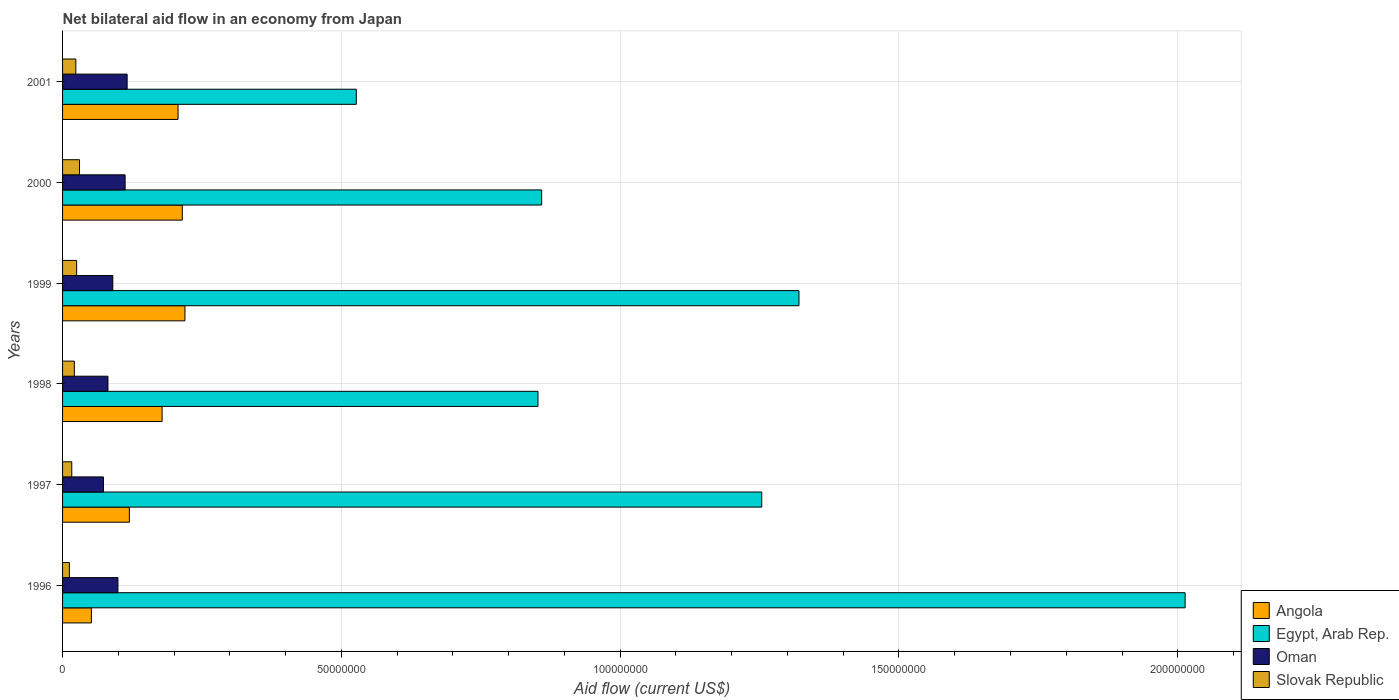How many different coloured bars are there?
Your response must be concise. 4. Are the number of bars on each tick of the Y-axis equal?
Provide a succinct answer. Yes. How many bars are there on the 1st tick from the top?
Provide a short and direct response. 4. How many bars are there on the 6th tick from the bottom?
Ensure brevity in your answer.  4. What is the label of the 6th group of bars from the top?
Provide a succinct answer. 1996. In how many cases, is the number of bars for a given year not equal to the number of legend labels?
Your answer should be compact. 0. What is the net bilateral aid flow in Oman in 1999?
Your response must be concise. 9.01e+06. Across all years, what is the maximum net bilateral aid flow in Angola?
Offer a very short reply. 2.20e+07. Across all years, what is the minimum net bilateral aid flow in Oman?
Provide a short and direct response. 7.33e+06. In which year was the net bilateral aid flow in Egypt, Arab Rep. maximum?
Provide a succinct answer. 1996. What is the total net bilateral aid flow in Slovak Republic in the graph?
Provide a succinct answer. 1.29e+07. What is the difference between the net bilateral aid flow in Angola in 1996 and that in 2001?
Give a very brief answer. -1.55e+07. What is the difference between the net bilateral aid flow in Oman in 2001 and the net bilateral aid flow in Egypt, Arab Rep. in 1999?
Provide a short and direct response. -1.20e+08. What is the average net bilateral aid flow in Oman per year?
Provide a short and direct response. 9.54e+06. In the year 1996, what is the difference between the net bilateral aid flow in Angola and net bilateral aid flow in Egypt, Arab Rep.?
Offer a terse response. -1.96e+08. What is the ratio of the net bilateral aid flow in Angola in 1999 to that in 2001?
Ensure brevity in your answer.  1.06. What is the difference between the highest and the second highest net bilateral aid flow in Egypt, Arab Rep.?
Your answer should be compact. 6.92e+07. What is the difference between the highest and the lowest net bilateral aid flow in Angola?
Offer a very short reply. 1.68e+07. In how many years, is the net bilateral aid flow in Angola greater than the average net bilateral aid flow in Angola taken over all years?
Your response must be concise. 4. Is it the case that in every year, the sum of the net bilateral aid flow in Egypt, Arab Rep. and net bilateral aid flow in Slovak Republic is greater than the sum of net bilateral aid flow in Oman and net bilateral aid flow in Angola?
Your answer should be very brief. No. What does the 4th bar from the top in 1997 represents?
Provide a succinct answer. Angola. What does the 1st bar from the bottom in 1997 represents?
Your answer should be very brief. Angola. Is it the case that in every year, the sum of the net bilateral aid flow in Oman and net bilateral aid flow in Slovak Republic is greater than the net bilateral aid flow in Egypt, Arab Rep.?
Your response must be concise. No. What is the difference between two consecutive major ticks on the X-axis?
Your response must be concise. 5.00e+07. Does the graph contain any zero values?
Your answer should be compact. No. Does the graph contain grids?
Ensure brevity in your answer.  Yes. How many legend labels are there?
Offer a very short reply. 4. What is the title of the graph?
Offer a very short reply. Net bilateral aid flow in an economy from Japan. Does "Myanmar" appear as one of the legend labels in the graph?
Offer a very short reply. No. What is the Aid flow (current US$) in Angola in 1996?
Ensure brevity in your answer.  5.17e+06. What is the Aid flow (current US$) in Egypt, Arab Rep. in 1996?
Provide a short and direct response. 2.01e+08. What is the Aid flow (current US$) in Oman in 1996?
Your answer should be compact. 9.93e+06. What is the Aid flow (current US$) in Slovak Republic in 1996?
Give a very brief answer. 1.22e+06. What is the Aid flow (current US$) of Angola in 1997?
Offer a very short reply. 1.20e+07. What is the Aid flow (current US$) in Egypt, Arab Rep. in 1997?
Keep it short and to the point. 1.25e+08. What is the Aid flow (current US$) in Oman in 1997?
Your answer should be compact. 7.33e+06. What is the Aid flow (current US$) in Slovak Republic in 1997?
Offer a very short reply. 1.65e+06. What is the Aid flow (current US$) of Angola in 1998?
Provide a succinct answer. 1.78e+07. What is the Aid flow (current US$) in Egypt, Arab Rep. in 1998?
Offer a terse response. 8.53e+07. What is the Aid flow (current US$) of Oman in 1998?
Offer a terse response. 8.14e+06. What is the Aid flow (current US$) in Slovak Republic in 1998?
Provide a short and direct response. 2.11e+06. What is the Aid flow (current US$) of Angola in 1999?
Provide a succinct answer. 2.20e+07. What is the Aid flow (current US$) of Egypt, Arab Rep. in 1999?
Provide a succinct answer. 1.32e+08. What is the Aid flow (current US$) of Oman in 1999?
Offer a very short reply. 9.01e+06. What is the Aid flow (current US$) in Slovak Republic in 1999?
Provide a short and direct response. 2.52e+06. What is the Aid flow (current US$) in Angola in 2000?
Provide a succinct answer. 2.15e+07. What is the Aid flow (current US$) of Egypt, Arab Rep. in 2000?
Your answer should be very brief. 8.59e+07. What is the Aid flow (current US$) of Oman in 2000?
Offer a terse response. 1.12e+07. What is the Aid flow (current US$) of Slovak Republic in 2000?
Your answer should be compact. 3.04e+06. What is the Aid flow (current US$) of Angola in 2001?
Provide a succinct answer. 2.07e+07. What is the Aid flow (current US$) of Egypt, Arab Rep. in 2001?
Offer a terse response. 5.27e+07. What is the Aid flow (current US$) of Oman in 2001?
Ensure brevity in your answer.  1.16e+07. What is the Aid flow (current US$) of Slovak Republic in 2001?
Keep it short and to the point. 2.38e+06. Across all years, what is the maximum Aid flow (current US$) of Angola?
Your answer should be compact. 2.20e+07. Across all years, what is the maximum Aid flow (current US$) in Egypt, Arab Rep.?
Your answer should be very brief. 2.01e+08. Across all years, what is the maximum Aid flow (current US$) in Oman?
Your answer should be very brief. 1.16e+07. Across all years, what is the maximum Aid flow (current US$) of Slovak Republic?
Give a very brief answer. 3.04e+06. Across all years, what is the minimum Aid flow (current US$) of Angola?
Offer a very short reply. 5.17e+06. Across all years, what is the minimum Aid flow (current US$) in Egypt, Arab Rep.?
Your response must be concise. 5.27e+07. Across all years, what is the minimum Aid flow (current US$) of Oman?
Give a very brief answer. 7.33e+06. Across all years, what is the minimum Aid flow (current US$) in Slovak Republic?
Provide a short and direct response. 1.22e+06. What is the total Aid flow (current US$) of Angola in the graph?
Ensure brevity in your answer.  9.91e+07. What is the total Aid flow (current US$) in Egypt, Arab Rep. in the graph?
Your answer should be compact. 6.83e+08. What is the total Aid flow (current US$) in Oman in the graph?
Make the answer very short. 5.72e+07. What is the total Aid flow (current US$) in Slovak Republic in the graph?
Keep it short and to the point. 1.29e+07. What is the difference between the Aid flow (current US$) of Angola in 1996 and that in 1997?
Provide a succinct answer. -6.81e+06. What is the difference between the Aid flow (current US$) in Egypt, Arab Rep. in 1996 and that in 1997?
Your answer should be very brief. 7.59e+07. What is the difference between the Aid flow (current US$) of Oman in 1996 and that in 1997?
Provide a succinct answer. 2.60e+06. What is the difference between the Aid flow (current US$) in Slovak Republic in 1996 and that in 1997?
Provide a succinct answer. -4.30e+05. What is the difference between the Aid flow (current US$) in Angola in 1996 and that in 1998?
Provide a short and direct response. -1.27e+07. What is the difference between the Aid flow (current US$) in Egypt, Arab Rep. in 1996 and that in 1998?
Offer a very short reply. 1.16e+08. What is the difference between the Aid flow (current US$) of Oman in 1996 and that in 1998?
Ensure brevity in your answer.  1.79e+06. What is the difference between the Aid flow (current US$) in Slovak Republic in 1996 and that in 1998?
Give a very brief answer. -8.90e+05. What is the difference between the Aid flow (current US$) in Angola in 1996 and that in 1999?
Make the answer very short. -1.68e+07. What is the difference between the Aid flow (current US$) in Egypt, Arab Rep. in 1996 and that in 1999?
Provide a short and direct response. 6.92e+07. What is the difference between the Aid flow (current US$) in Oman in 1996 and that in 1999?
Your answer should be very brief. 9.20e+05. What is the difference between the Aid flow (current US$) in Slovak Republic in 1996 and that in 1999?
Offer a very short reply. -1.30e+06. What is the difference between the Aid flow (current US$) in Angola in 1996 and that in 2000?
Provide a succinct answer. -1.63e+07. What is the difference between the Aid flow (current US$) in Egypt, Arab Rep. in 1996 and that in 2000?
Offer a very short reply. 1.15e+08. What is the difference between the Aid flow (current US$) of Oman in 1996 and that in 2000?
Offer a terse response. -1.29e+06. What is the difference between the Aid flow (current US$) of Slovak Republic in 1996 and that in 2000?
Your response must be concise. -1.82e+06. What is the difference between the Aid flow (current US$) in Angola in 1996 and that in 2001?
Provide a short and direct response. -1.55e+07. What is the difference between the Aid flow (current US$) of Egypt, Arab Rep. in 1996 and that in 2001?
Your answer should be compact. 1.49e+08. What is the difference between the Aid flow (current US$) in Oman in 1996 and that in 2001?
Ensure brevity in your answer.  -1.65e+06. What is the difference between the Aid flow (current US$) in Slovak Republic in 1996 and that in 2001?
Your response must be concise. -1.16e+06. What is the difference between the Aid flow (current US$) of Angola in 1997 and that in 1998?
Ensure brevity in your answer.  -5.87e+06. What is the difference between the Aid flow (current US$) in Egypt, Arab Rep. in 1997 and that in 1998?
Ensure brevity in your answer.  4.01e+07. What is the difference between the Aid flow (current US$) in Oman in 1997 and that in 1998?
Your response must be concise. -8.10e+05. What is the difference between the Aid flow (current US$) in Slovak Republic in 1997 and that in 1998?
Ensure brevity in your answer.  -4.60e+05. What is the difference between the Aid flow (current US$) of Angola in 1997 and that in 1999?
Provide a short and direct response. -9.97e+06. What is the difference between the Aid flow (current US$) of Egypt, Arab Rep. in 1997 and that in 1999?
Your answer should be compact. -6.68e+06. What is the difference between the Aid flow (current US$) of Oman in 1997 and that in 1999?
Offer a terse response. -1.68e+06. What is the difference between the Aid flow (current US$) in Slovak Republic in 1997 and that in 1999?
Offer a terse response. -8.70e+05. What is the difference between the Aid flow (current US$) in Angola in 1997 and that in 2000?
Offer a very short reply. -9.49e+06. What is the difference between the Aid flow (current US$) of Egypt, Arab Rep. in 1997 and that in 2000?
Your response must be concise. 3.95e+07. What is the difference between the Aid flow (current US$) of Oman in 1997 and that in 2000?
Offer a terse response. -3.89e+06. What is the difference between the Aid flow (current US$) in Slovak Republic in 1997 and that in 2000?
Provide a short and direct response. -1.39e+06. What is the difference between the Aid flow (current US$) in Angola in 1997 and that in 2001?
Your response must be concise. -8.73e+06. What is the difference between the Aid flow (current US$) in Egypt, Arab Rep. in 1997 and that in 2001?
Ensure brevity in your answer.  7.27e+07. What is the difference between the Aid flow (current US$) of Oman in 1997 and that in 2001?
Offer a terse response. -4.25e+06. What is the difference between the Aid flow (current US$) in Slovak Republic in 1997 and that in 2001?
Offer a very short reply. -7.30e+05. What is the difference between the Aid flow (current US$) in Angola in 1998 and that in 1999?
Keep it short and to the point. -4.10e+06. What is the difference between the Aid flow (current US$) of Egypt, Arab Rep. in 1998 and that in 1999?
Give a very brief answer. -4.68e+07. What is the difference between the Aid flow (current US$) of Oman in 1998 and that in 1999?
Keep it short and to the point. -8.70e+05. What is the difference between the Aid flow (current US$) of Slovak Republic in 1998 and that in 1999?
Your answer should be very brief. -4.10e+05. What is the difference between the Aid flow (current US$) in Angola in 1998 and that in 2000?
Keep it short and to the point. -3.62e+06. What is the difference between the Aid flow (current US$) in Egypt, Arab Rep. in 1998 and that in 2000?
Keep it short and to the point. -6.60e+05. What is the difference between the Aid flow (current US$) in Oman in 1998 and that in 2000?
Your response must be concise. -3.08e+06. What is the difference between the Aid flow (current US$) in Slovak Republic in 1998 and that in 2000?
Provide a short and direct response. -9.30e+05. What is the difference between the Aid flow (current US$) of Angola in 1998 and that in 2001?
Make the answer very short. -2.86e+06. What is the difference between the Aid flow (current US$) of Egypt, Arab Rep. in 1998 and that in 2001?
Offer a very short reply. 3.26e+07. What is the difference between the Aid flow (current US$) in Oman in 1998 and that in 2001?
Keep it short and to the point. -3.44e+06. What is the difference between the Aid flow (current US$) of Angola in 1999 and that in 2000?
Provide a short and direct response. 4.80e+05. What is the difference between the Aid flow (current US$) of Egypt, Arab Rep. in 1999 and that in 2000?
Keep it short and to the point. 4.62e+07. What is the difference between the Aid flow (current US$) in Oman in 1999 and that in 2000?
Keep it short and to the point. -2.21e+06. What is the difference between the Aid flow (current US$) in Slovak Republic in 1999 and that in 2000?
Your answer should be compact. -5.20e+05. What is the difference between the Aid flow (current US$) of Angola in 1999 and that in 2001?
Make the answer very short. 1.24e+06. What is the difference between the Aid flow (current US$) of Egypt, Arab Rep. in 1999 and that in 2001?
Your answer should be compact. 7.94e+07. What is the difference between the Aid flow (current US$) in Oman in 1999 and that in 2001?
Offer a very short reply. -2.57e+06. What is the difference between the Aid flow (current US$) of Slovak Republic in 1999 and that in 2001?
Provide a succinct answer. 1.40e+05. What is the difference between the Aid flow (current US$) of Angola in 2000 and that in 2001?
Ensure brevity in your answer.  7.60e+05. What is the difference between the Aid flow (current US$) of Egypt, Arab Rep. in 2000 and that in 2001?
Your answer should be very brief. 3.32e+07. What is the difference between the Aid flow (current US$) in Oman in 2000 and that in 2001?
Offer a very short reply. -3.60e+05. What is the difference between the Aid flow (current US$) of Angola in 1996 and the Aid flow (current US$) of Egypt, Arab Rep. in 1997?
Give a very brief answer. -1.20e+08. What is the difference between the Aid flow (current US$) of Angola in 1996 and the Aid flow (current US$) of Oman in 1997?
Offer a very short reply. -2.16e+06. What is the difference between the Aid flow (current US$) of Angola in 1996 and the Aid flow (current US$) of Slovak Republic in 1997?
Make the answer very short. 3.52e+06. What is the difference between the Aid flow (current US$) in Egypt, Arab Rep. in 1996 and the Aid flow (current US$) in Oman in 1997?
Provide a short and direct response. 1.94e+08. What is the difference between the Aid flow (current US$) of Egypt, Arab Rep. in 1996 and the Aid flow (current US$) of Slovak Republic in 1997?
Your answer should be compact. 2.00e+08. What is the difference between the Aid flow (current US$) in Oman in 1996 and the Aid flow (current US$) in Slovak Republic in 1997?
Give a very brief answer. 8.28e+06. What is the difference between the Aid flow (current US$) of Angola in 1996 and the Aid flow (current US$) of Egypt, Arab Rep. in 1998?
Your answer should be compact. -8.01e+07. What is the difference between the Aid flow (current US$) of Angola in 1996 and the Aid flow (current US$) of Oman in 1998?
Your response must be concise. -2.97e+06. What is the difference between the Aid flow (current US$) of Angola in 1996 and the Aid flow (current US$) of Slovak Republic in 1998?
Your answer should be very brief. 3.06e+06. What is the difference between the Aid flow (current US$) in Egypt, Arab Rep. in 1996 and the Aid flow (current US$) in Oman in 1998?
Ensure brevity in your answer.  1.93e+08. What is the difference between the Aid flow (current US$) in Egypt, Arab Rep. in 1996 and the Aid flow (current US$) in Slovak Republic in 1998?
Keep it short and to the point. 1.99e+08. What is the difference between the Aid flow (current US$) of Oman in 1996 and the Aid flow (current US$) of Slovak Republic in 1998?
Offer a very short reply. 7.82e+06. What is the difference between the Aid flow (current US$) of Angola in 1996 and the Aid flow (current US$) of Egypt, Arab Rep. in 1999?
Keep it short and to the point. -1.27e+08. What is the difference between the Aid flow (current US$) of Angola in 1996 and the Aid flow (current US$) of Oman in 1999?
Provide a succinct answer. -3.84e+06. What is the difference between the Aid flow (current US$) of Angola in 1996 and the Aid flow (current US$) of Slovak Republic in 1999?
Give a very brief answer. 2.65e+06. What is the difference between the Aid flow (current US$) of Egypt, Arab Rep. in 1996 and the Aid flow (current US$) of Oman in 1999?
Provide a short and direct response. 1.92e+08. What is the difference between the Aid flow (current US$) in Egypt, Arab Rep. in 1996 and the Aid flow (current US$) in Slovak Republic in 1999?
Your response must be concise. 1.99e+08. What is the difference between the Aid flow (current US$) of Oman in 1996 and the Aid flow (current US$) of Slovak Republic in 1999?
Your answer should be very brief. 7.41e+06. What is the difference between the Aid flow (current US$) in Angola in 1996 and the Aid flow (current US$) in Egypt, Arab Rep. in 2000?
Your answer should be compact. -8.08e+07. What is the difference between the Aid flow (current US$) in Angola in 1996 and the Aid flow (current US$) in Oman in 2000?
Keep it short and to the point. -6.05e+06. What is the difference between the Aid flow (current US$) of Angola in 1996 and the Aid flow (current US$) of Slovak Republic in 2000?
Give a very brief answer. 2.13e+06. What is the difference between the Aid flow (current US$) of Egypt, Arab Rep. in 1996 and the Aid flow (current US$) of Oman in 2000?
Offer a very short reply. 1.90e+08. What is the difference between the Aid flow (current US$) in Egypt, Arab Rep. in 1996 and the Aid flow (current US$) in Slovak Republic in 2000?
Ensure brevity in your answer.  1.98e+08. What is the difference between the Aid flow (current US$) in Oman in 1996 and the Aid flow (current US$) in Slovak Republic in 2000?
Make the answer very short. 6.89e+06. What is the difference between the Aid flow (current US$) in Angola in 1996 and the Aid flow (current US$) in Egypt, Arab Rep. in 2001?
Keep it short and to the point. -4.75e+07. What is the difference between the Aid flow (current US$) in Angola in 1996 and the Aid flow (current US$) in Oman in 2001?
Your response must be concise. -6.41e+06. What is the difference between the Aid flow (current US$) in Angola in 1996 and the Aid flow (current US$) in Slovak Republic in 2001?
Provide a short and direct response. 2.79e+06. What is the difference between the Aid flow (current US$) of Egypt, Arab Rep. in 1996 and the Aid flow (current US$) of Oman in 2001?
Offer a terse response. 1.90e+08. What is the difference between the Aid flow (current US$) of Egypt, Arab Rep. in 1996 and the Aid flow (current US$) of Slovak Republic in 2001?
Your response must be concise. 1.99e+08. What is the difference between the Aid flow (current US$) of Oman in 1996 and the Aid flow (current US$) of Slovak Republic in 2001?
Provide a short and direct response. 7.55e+06. What is the difference between the Aid flow (current US$) in Angola in 1997 and the Aid flow (current US$) in Egypt, Arab Rep. in 1998?
Keep it short and to the point. -7.33e+07. What is the difference between the Aid flow (current US$) in Angola in 1997 and the Aid flow (current US$) in Oman in 1998?
Provide a short and direct response. 3.84e+06. What is the difference between the Aid flow (current US$) in Angola in 1997 and the Aid flow (current US$) in Slovak Republic in 1998?
Keep it short and to the point. 9.87e+06. What is the difference between the Aid flow (current US$) of Egypt, Arab Rep. in 1997 and the Aid flow (current US$) of Oman in 1998?
Give a very brief answer. 1.17e+08. What is the difference between the Aid flow (current US$) of Egypt, Arab Rep. in 1997 and the Aid flow (current US$) of Slovak Republic in 1998?
Offer a very short reply. 1.23e+08. What is the difference between the Aid flow (current US$) of Oman in 1997 and the Aid flow (current US$) of Slovak Republic in 1998?
Provide a succinct answer. 5.22e+06. What is the difference between the Aid flow (current US$) in Angola in 1997 and the Aid flow (current US$) in Egypt, Arab Rep. in 1999?
Offer a terse response. -1.20e+08. What is the difference between the Aid flow (current US$) in Angola in 1997 and the Aid flow (current US$) in Oman in 1999?
Your answer should be very brief. 2.97e+06. What is the difference between the Aid flow (current US$) in Angola in 1997 and the Aid flow (current US$) in Slovak Republic in 1999?
Your answer should be compact. 9.46e+06. What is the difference between the Aid flow (current US$) in Egypt, Arab Rep. in 1997 and the Aid flow (current US$) in Oman in 1999?
Your response must be concise. 1.16e+08. What is the difference between the Aid flow (current US$) of Egypt, Arab Rep. in 1997 and the Aid flow (current US$) of Slovak Republic in 1999?
Make the answer very short. 1.23e+08. What is the difference between the Aid flow (current US$) in Oman in 1997 and the Aid flow (current US$) in Slovak Republic in 1999?
Your answer should be compact. 4.81e+06. What is the difference between the Aid flow (current US$) of Angola in 1997 and the Aid flow (current US$) of Egypt, Arab Rep. in 2000?
Your response must be concise. -7.39e+07. What is the difference between the Aid flow (current US$) of Angola in 1997 and the Aid flow (current US$) of Oman in 2000?
Offer a very short reply. 7.60e+05. What is the difference between the Aid flow (current US$) of Angola in 1997 and the Aid flow (current US$) of Slovak Republic in 2000?
Offer a very short reply. 8.94e+06. What is the difference between the Aid flow (current US$) of Egypt, Arab Rep. in 1997 and the Aid flow (current US$) of Oman in 2000?
Make the answer very short. 1.14e+08. What is the difference between the Aid flow (current US$) of Egypt, Arab Rep. in 1997 and the Aid flow (current US$) of Slovak Republic in 2000?
Your answer should be compact. 1.22e+08. What is the difference between the Aid flow (current US$) in Oman in 1997 and the Aid flow (current US$) in Slovak Republic in 2000?
Your answer should be very brief. 4.29e+06. What is the difference between the Aid flow (current US$) of Angola in 1997 and the Aid flow (current US$) of Egypt, Arab Rep. in 2001?
Make the answer very short. -4.07e+07. What is the difference between the Aid flow (current US$) in Angola in 1997 and the Aid flow (current US$) in Slovak Republic in 2001?
Your response must be concise. 9.60e+06. What is the difference between the Aid flow (current US$) in Egypt, Arab Rep. in 1997 and the Aid flow (current US$) in Oman in 2001?
Your answer should be very brief. 1.14e+08. What is the difference between the Aid flow (current US$) of Egypt, Arab Rep. in 1997 and the Aid flow (current US$) of Slovak Republic in 2001?
Ensure brevity in your answer.  1.23e+08. What is the difference between the Aid flow (current US$) of Oman in 1997 and the Aid flow (current US$) of Slovak Republic in 2001?
Provide a succinct answer. 4.95e+06. What is the difference between the Aid flow (current US$) of Angola in 1998 and the Aid flow (current US$) of Egypt, Arab Rep. in 1999?
Make the answer very short. -1.14e+08. What is the difference between the Aid flow (current US$) of Angola in 1998 and the Aid flow (current US$) of Oman in 1999?
Your response must be concise. 8.84e+06. What is the difference between the Aid flow (current US$) of Angola in 1998 and the Aid flow (current US$) of Slovak Republic in 1999?
Make the answer very short. 1.53e+07. What is the difference between the Aid flow (current US$) of Egypt, Arab Rep. in 1998 and the Aid flow (current US$) of Oman in 1999?
Make the answer very short. 7.62e+07. What is the difference between the Aid flow (current US$) of Egypt, Arab Rep. in 1998 and the Aid flow (current US$) of Slovak Republic in 1999?
Make the answer very short. 8.27e+07. What is the difference between the Aid flow (current US$) of Oman in 1998 and the Aid flow (current US$) of Slovak Republic in 1999?
Ensure brevity in your answer.  5.62e+06. What is the difference between the Aid flow (current US$) of Angola in 1998 and the Aid flow (current US$) of Egypt, Arab Rep. in 2000?
Offer a very short reply. -6.81e+07. What is the difference between the Aid flow (current US$) of Angola in 1998 and the Aid flow (current US$) of Oman in 2000?
Your answer should be compact. 6.63e+06. What is the difference between the Aid flow (current US$) of Angola in 1998 and the Aid flow (current US$) of Slovak Republic in 2000?
Make the answer very short. 1.48e+07. What is the difference between the Aid flow (current US$) in Egypt, Arab Rep. in 1998 and the Aid flow (current US$) in Oman in 2000?
Give a very brief answer. 7.40e+07. What is the difference between the Aid flow (current US$) in Egypt, Arab Rep. in 1998 and the Aid flow (current US$) in Slovak Republic in 2000?
Provide a short and direct response. 8.22e+07. What is the difference between the Aid flow (current US$) in Oman in 1998 and the Aid flow (current US$) in Slovak Republic in 2000?
Provide a succinct answer. 5.10e+06. What is the difference between the Aid flow (current US$) in Angola in 1998 and the Aid flow (current US$) in Egypt, Arab Rep. in 2001?
Offer a terse response. -3.48e+07. What is the difference between the Aid flow (current US$) of Angola in 1998 and the Aid flow (current US$) of Oman in 2001?
Provide a succinct answer. 6.27e+06. What is the difference between the Aid flow (current US$) of Angola in 1998 and the Aid flow (current US$) of Slovak Republic in 2001?
Provide a succinct answer. 1.55e+07. What is the difference between the Aid flow (current US$) of Egypt, Arab Rep. in 1998 and the Aid flow (current US$) of Oman in 2001?
Offer a very short reply. 7.37e+07. What is the difference between the Aid flow (current US$) of Egypt, Arab Rep. in 1998 and the Aid flow (current US$) of Slovak Republic in 2001?
Give a very brief answer. 8.29e+07. What is the difference between the Aid flow (current US$) in Oman in 1998 and the Aid flow (current US$) in Slovak Republic in 2001?
Your answer should be compact. 5.76e+06. What is the difference between the Aid flow (current US$) of Angola in 1999 and the Aid flow (current US$) of Egypt, Arab Rep. in 2000?
Provide a short and direct response. -6.40e+07. What is the difference between the Aid flow (current US$) in Angola in 1999 and the Aid flow (current US$) in Oman in 2000?
Your answer should be very brief. 1.07e+07. What is the difference between the Aid flow (current US$) of Angola in 1999 and the Aid flow (current US$) of Slovak Republic in 2000?
Your response must be concise. 1.89e+07. What is the difference between the Aid flow (current US$) in Egypt, Arab Rep. in 1999 and the Aid flow (current US$) in Oman in 2000?
Ensure brevity in your answer.  1.21e+08. What is the difference between the Aid flow (current US$) in Egypt, Arab Rep. in 1999 and the Aid flow (current US$) in Slovak Republic in 2000?
Ensure brevity in your answer.  1.29e+08. What is the difference between the Aid flow (current US$) of Oman in 1999 and the Aid flow (current US$) of Slovak Republic in 2000?
Ensure brevity in your answer.  5.97e+06. What is the difference between the Aid flow (current US$) of Angola in 1999 and the Aid flow (current US$) of Egypt, Arab Rep. in 2001?
Give a very brief answer. -3.07e+07. What is the difference between the Aid flow (current US$) of Angola in 1999 and the Aid flow (current US$) of Oman in 2001?
Your response must be concise. 1.04e+07. What is the difference between the Aid flow (current US$) of Angola in 1999 and the Aid flow (current US$) of Slovak Republic in 2001?
Provide a succinct answer. 1.96e+07. What is the difference between the Aid flow (current US$) in Egypt, Arab Rep. in 1999 and the Aid flow (current US$) in Oman in 2001?
Provide a short and direct response. 1.20e+08. What is the difference between the Aid flow (current US$) in Egypt, Arab Rep. in 1999 and the Aid flow (current US$) in Slovak Republic in 2001?
Ensure brevity in your answer.  1.30e+08. What is the difference between the Aid flow (current US$) in Oman in 1999 and the Aid flow (current US$) in Slovak Republic in 2001?
Offer a terse response. 6.63e+06. What is the difference between the Aid flow (current US$) of Angola in 2000 and the Aid flow (current US$) of Egypt, Arab Rep. in 2001?
Your response must be concise. -3.12e+07. What is the difference between the Aid flow (current US$) in Angola in 2000 and the Aid flow (current US$) in Oman in 2001?
Your answer should be compact. 9.89e+06. What is the difference between the Aid flow (current US$) of Angola in 2000 and the Aid flow (current US$) of Slovak Republic in 2001?
Your response must be concise. 1.91e+07. What is the difference between the Aid flow (current US$) of Egypt, Arab Rep. in 2000 and the Aid flow (current US$) of Oman in 2001?
Your response must be concise. 7.43e+07. What is the difference between the Aid flow (current US$) of Egypt, Arab Rep. in 2000 and the Aid flow (current US$) of Slovak Republic in 2001?
Give a very brief answer. 8.35e+07. What is the difference between the Aid flow (current US$) in Oman in 2000 and the Aid flow (current US$) in Slovak Republic in 2001?
Offer a very short reply. 8.84e+06. What is the average Aid flow (current US$) of Angola per year?
Make the answer very short. 1.65e+07. What is the average Aid flow (current US$) of Egypt, Arab Rep. per year?
Ensure brevity in your answer.  1.14e+08. What is the average Aid flow (current US$) in Oman per year?
Ensure brevity in your answer.  9.54e+06. What is the average Aid flow (current US$) of Slovak Republic per year?
Give a very brief answer. 2.15e+06. In the year 1996, what is the difference between the Aid flow (current US$) of Angola and Aid flow (current US$) of Egypt, Arab Rep.?
Offer a terse response. -1.96e+08. In the year 1996, what is the difference between the Aid flow (current US$) of Angola and Aid flow (current US$) of Oman?
Your answer should be compact. -4.76e+06. In the year 1996, what is the difference between the Aid flow (current US$) of Angola and Aid flow (current US$) of Slovak Republic?
Provide a succinct answer. 3.95e+06. In the year 1996, what is the difference between the Aid flow (current US$) in Egypt, Arab Rep. and Aid flow (current US$) in Oman?
Your answer should be compact. 1.91e+08. In the year 1996, what is the difference between the Aid flow (current US$) of Egypt, Arab Rep. and Aid flow (current US$) of Slovak Republic?
Your response must be concise. 2.00e+08. In the year 1996, what is the difference between the Aid flow (current US$) in Oman and Aid flow (current US$) in Slovak Republic?
Provide a succinct answer. 8.71e+06. In the year 1997, what is the difference between the Aid flow (current US$) in Angola and Aid flow (current US$) in Egypt, Arab Rep.?
Make the answer very short. -1.13e+08. In the year 1997, what is the difference between the Aid flow (current US$) in Angola and Aid flow (current US$) in Oman?
Ensure brevity in your answer.  4.65e+06. In the year 1997, what is the difference between the Aid flow (current US$) of Angola and Aid flow (current US$) of Slovak Republic?
Provide a short and direct response. 1.03e+07. In the year 1997, what is the difference between the Aid flow (current US$) of Egypt, Arab Rep. and Aid flow (current US$) of Oman?
Make the answer very short. 1.18e+08. In the year 1997, what is the difference between the Aid flow (current US$) of Egypt, Arab Rep. and Aid flow (current US$) of Slovak Republic?
Give a very brief answer. 1.24e+08. In the year 1997, what is the difference between the Aid flow (current US$) of Oman and Aid flow (current US$) of Slovak Republic?
Offer a very short reply. 5.68e+06. In the year 1998, what is the difference between the Aid flow (current US$) of Angola and Aid flow (current US$) of Egypt, Arab Rep.?
Ensure brevity in your answer.  -6.74e+07. In the year 1998, what is the difference between the Aid flow (current US$) of Angola and Aid flow (current US$) of Oman?
Your answer should be compact. 9.71e+06. In the year 1998, what is the difference between the Aid flow (current US$) in Angola and Aid flow (current US$) in Slovak Republic?
Keep it short and to the point. 1.57e+07. In the year 1998, what is the difference between the Aid flow (current US$) in Egypt, Arab Rep. and Aid flow (current US$) in Oman?
Keep it short and to the point. 7.71e+07. In the year 1998, what is the difference between the Aid flow (current US$) of Egypt, Arab Rep. and Aid flow (current US$) of Slovak Republic?
Your answer should be compact. 8.32e+07. In the year 1998, what is the difference between the Aid flow (current US$) of Oman and Aid flow (current US$) of Slovak Republic?
Keep it short and to the point. 6.03e+06. In the year 1999, what is the difference between the Aid flow (current US$) in Angola and Aid flow (current US$) in Egypt, Arab Rep.?
Give a very brief answer. -1.10e+08. In the year 1999, what is the difference between the Aid flow (current US$) of Angola and Aid flow (current US$) of Oman?
Provide a short and direct response. 1.29e+07. In the year 1999, what is the difference between the Aid flow (current US$) in Angola and Aid flow (current US$) in Slovak Republic?
Your response must be concise. 1.94e+07. In the year 1999, what is the difference between the Aid flow (current US$) of Egypt, Arab Rep. and Aid flow (current US$) of Oman?
Offer a terse response. 1.23e+08. In the year 1999, what is the difference between the Aid flow (current US$) of Egypt, Arab Rep. and Aid flow (current US$) of Slovak Republic?
Offer a terse response. 1.30e+08. In the year 1999, what is the difference between the Aid flow (current US$) in Oman and Aid flow (current US$) in Slovak Republic?
Provide a short and direct response. 6.49e+06. In the year 2000, what is the difference between the Aid flow (current US$) of Angola and Aid flow (current US$) of Egypt, Arab Rep.?
Your answer should be compact. -6.44e+07. In the year 2000, what is the difference between the Aid flow (current US$) of Angola and Aid flow (current US$) of Oman?
Give a very brief answer. 1.02e+07. In the year 2000, what is the difference between the Aid flow (current US$) of Angola and Aid flow (current US$) of Slovak Republic?
Ensure brevity in your answer.  1.84e+07. In the year 2000, what is the difference between the Aid flow (current US$) of Egypt, Arab Rep. and Aid flow (current US$) of Oman?
Provide a short and direct response. 7.47e+07. In the year 2000, what is the difference between the Aid flow (current US$) in Egypt, Arab Rep. and Aid flow (current US$) in Slovak Republic?
Your answer should be very brief. 8.29e+07. In the year 2000, what is the difference between the Aid flow (current US$) in Oman and Aid flow (current US$) in Slovak Republic?
Ensure brevity in your answer.  8.18e+06. In the year 2001, what is the difference between the Aid flow (current US$) in Angola and Aid flow (current US$) in Egypt, Arab Rep.?
Offer a very short reply. -3.20e+07. In the year 2001, what is the difference between the Aid flow (current US$) of Angola and Aid flow (current US$) of Oman?
Your answer should be compact. 9.13e+06. In the year 2001, what is the difference between the Aid flow (current US$) in Angola and Aid flow (current US$) in Slovak Republic?
Your response must be concise. 1.83e+07. In the year 2001, what is the difference between the Aid flow (current US$) in Egypt, Arab Rep. and Aid flow (current US$) in Oman?
Make the answer very short. 4.11e+07. In the year 2001, what is the difference between the Aid flow (current US$) in Egypt, Arab Rep. and Aid flow (current US$) in Slovak Republic?
Offer a terse response. 5.03e+07. In the year 2001, what is the difference between the Aid flow (current US$) of Oman and Aid flow (current US$) of Slovak Republic?
Provide a succinct answer. 9.20e+06. What is the ratio of the Aid flow (current US$) of Angola in 1996 to that in 1997?
Offer a very short reply. 0.43. What is the ratio of the Aid flow (current US$) of Egypt, Arab Rep. in 1996 to that in 1997?
Your answer should be very brief. 1.61. What is the ratio of the Aid flow (current US$) of Oman in 1996 to that in 1997?
Offer a terse response. 1.35. What is the ratio of the Aid flow (current US$) of Slovak Republic in 1996 to that in 1997?
Ensure brevity in your answer.  0.74. What is the ratio of the Aid flow (current US$) in Angola in 1996 to that in 1998?
Your response must be concise. 0.29. What is the ratio of the Aid flow (current US$) of Egypt, Arab Rep. in 1996 to that in 1998?
Your answer should be compact. 2.36. What is the ratio of the Aid flow (current US$) of Oman in 1996 to that in 1998?
Give a very brief answer. 1.22. What is the ratio of the Aid flow (current US$) in Slovak Republic in 1996 to that in 1998?
Make the answer very short. 0.58. What is the ratio of the Aid flow (current US$) in Angola in 1996 to that in 1999?
Provide a succinct answer. 0.24. What is the ratio of the Aid flow (current US$) of Egypt, Arab Rep. in 1996 to that in 1999?
Your response must be concise. 1.52. What is the ratio of the Aid flow (current US$) in Oman in 1996 to that in 1999?
Your answer should be compact. 1.1. What is the ratio of the Aid flow (current US$) in Slovak Republic in 1996 to that in 1999?
Your answer should be very brief. 0.48. What is the ratio of the Aid flow (current US$) of Angola in 1996 to that in 2000?
Offer a terse response. 0.24. What is the ratio of the Aid flow (current US$) in Egypt, Arab Rep. in 1996 to that in 2000?
Keep it short and to the point. 2.34. What is the ratio of the Aid flow (current US$) in Oman in 1996 to that in 2000?
Keep it short and to the point. 0.89. What is the ratio of the Aid flow (current US$) in Slovak Republic in 1996 to that in 2000?
Offer a terse response. 0.4. What is the ratio of the Aid flow (current US$) of Angola in 1996 to that in 2001?
Provide a short and direct response. 0.25. What is the ratio of the Aid flow (current US$) in Egypt, Arab Rep. in 1996 to that in 2001?
Give a very brief answer. 3.82. What is the ratio of the Aid flow (current US$) of Oman in 1996 to that in 2001?
Your answer should be very brief. 0.86. What is the ratio of the Aid flow (current US$) of Slovak Republic in 1996 to that in 2001?
Offer a terse response. 0.51. What is the ratio of the Aid flow (current US$) of Angola in 1997 to that in 1998?
Make the answer very short. 0.67. What is the ratio of the Aid flow (current US$) of Egypt, Arab Rep. in 1997 to that in 1998?
Keep it short and to the point. 1.47. What is the ratio of the Aid flow (current US$) of Oman in 1997 to that in 1998?
Keep it short and to the point. 0.9. What is the ratio of the Aid flow (current US$) in Slovak Republic in 1997 to that in 1998?
Provide a succinct answer. 0.78. What is the ratio of the Aid flow (current US$) in Angola in 1997 to that in 1999?
Offer a very short reply. 0.55. What is the ratio of the Aid flow (current US$) of Egypt, Arab Rep. in 1997 to that in 1999?
Make the answer very short. 0.95. What is the ratio of the Aid flow (current US$) in Oman in 1997 to that in 1999?
Ensure brevity in your answer.  0.81. What is the ratio of the Aid flow (current US$) of Slovak Republic in 1997 to that in 1999?
Provide a short and direct response. 0.65. What is the ratio of the Aid flow (current US$) in Angola in 1997 to that in 2000?
Offer a very short reply. 0.56. What is the ratio of the Aid flow (current US$) in Egypt, Arab Rep. in 1997 to that in 2000?
Your response must be concise. 1.46. What is the ratio of the Aid flow (current US$) in Oman in 1997 to that in 2000?
Your answer should be very brief. 0.65. What is the ratio of the Aid flow (current US$) of Slovak Republic in 1997 to that in 2000?
Your response must be concise. 0.54. What is the ratio of the Aid flow (current US$) of Angola in 1997 to that in 2001?
Your answer should be compact. 0.58. What is the ratio of the Aid flow (current US$) in Egypt, Arab Rep. in 1997 to that in 2001?
Your answer should be compact. 2.38. What is the ratio of the Aid flow (current US$) in Oman in 1997 to that in 2001?
Offer a very short reply. 0.63. What is the ratio of the Aid flow (current US$) in Slovak Republic in 1997 to that in 2001?
Provide a short and direct response. 0.69. What is the ratio of the Aid flow (current US$) of Angola in 1998 to that in 1999?
Keep it short and to the point. 0.81. What is the ratio of the Aid flow (current US$) in Egypt, Arab Rep. in 1998 to that in 1999?
Provide a short and direct response. 0.65. What is the ratio of the Aid flow (current US$) in Oman in 1998 to that in 1999?
Provide a succinct answer. 0.9. What is the ratio of the Aid flow (current US$) of Slovak Republic in 1998 to that in 1999?
Provide a short and direct response. 0.84. What is the ratio of the Aid flow (current US$) in Angola in 1998 to that in 2000?
Your response must be concise. 0.83. What is the ratio of the Aid flow (current US$) in Egypt, Arab Rep. in 1998 to that in 2000?
Provide a short and direct response. 0.99. What is the ratio of the Aid flow (current US$) in Oman in 1998 to that in 2000?
Your response must be concise. 0.73. What is the ratio of the Aid flow (current US$) of Slovak Republic in 1998 to that in 2000?
Offer a terse response. 0.69. What is the ratio of the Aid flow (current US$) in Angola in 1998 to that in 2001?
Provide a short and direct response. 0.86. What is the ratio of the Aid flow (current US$) in Egypt, Arab Rep. in 1998 to that in 2001?
Keep it short and to the point. 1.62. What is the ratio of the Aid flow (current US$) of Oman in 1998 to that in 2001?
Your answer should be compact. 0.7. What is the ratio of the Aid flow (current US$) of Slovak Republic in 1998 to that in 2001?
Give a very brief answer. 0.89. What is the ratio of the Aid flow (current US$) in Angola in 1999 to that in 2000?
Ensure brevity in your answer.  1.02. What is the ratio of the Aid flow (current US$) in Egypt, Arab Rep. in 1999 to that in 2000?
Provide a succinct answer. 1.54. What is the ratio of the Aid flow (current US$) of Oman in 1999 to that in 2000?
Your response must be concise. 0.8. What is the ratio of the Aid flow (current US$) in Slovak Republic in 1999 to that in 2000?
Provide a succinct answer. 0.83. What is the ratio of the Aid flow (current US$) in Angola in 1999 to that in 2001?
Provide a short and direct response. 1.06. What is the ratio of the Aid flow (current US$) of Egypt, Arab Rep. in 1999 to that in 2001?
Provide a succinct answer. 2.51. What is the ratio of the Aid flow (current US$) in Oman in 1999 to that in 2001?
Give a very brief answer. 0.78. What is the ratio of the Aid flow (current US$) in Slovak Republic in 1999 to that in 2001?
Provide a short and direct response. 1.06. What is the ratio of the Aid flow (current US$) of Angola in 2000 to that in 2001?
Offer a very short reply. 1.04. What is the ratio of the Aid flow (current US$) in Egypt, Arab Rep. in 2000 to that in 2001?
Provide a short and direct response. 1.63. What is the ratio of the Aid flow (current US$) of Oman in 2000 to that in 2001?
Your answer should be compact. 0.97. What is the ratio of the Aid flow (current US$) of Slovak Republic in 2000 to that in 2001?
Make the answer very short. 1.28. What is the difference between the highest and the second highest Aid flow (current US$) of Egypt, Arab Rep.?
Your answer should be very brief. 6.92e+07. What is the difference between the highest and the second highest Aid flow (current US$) in Slovak Republic?
Your response must be concise. 5.20e+05. What is the difference between the highest and the lowest Aid flow (current US$) of Angola?
Provide a succinct answer. 1.68e+07. What is the difference between the highest and the lowest Aid flow (current US$) in Egypt, Arab Rep.?
Provide a succinct answer. 1.49e+08. What is the difference between the highest and the lowest Aid flow (current US$) in Oman?
Ensure brevity in your answer.  4.25e+06. What is the difference between the highest and the lowest Aid flow (current US$) in Slovak Republic?
Provide a succinct answer. 1.82e+06. 